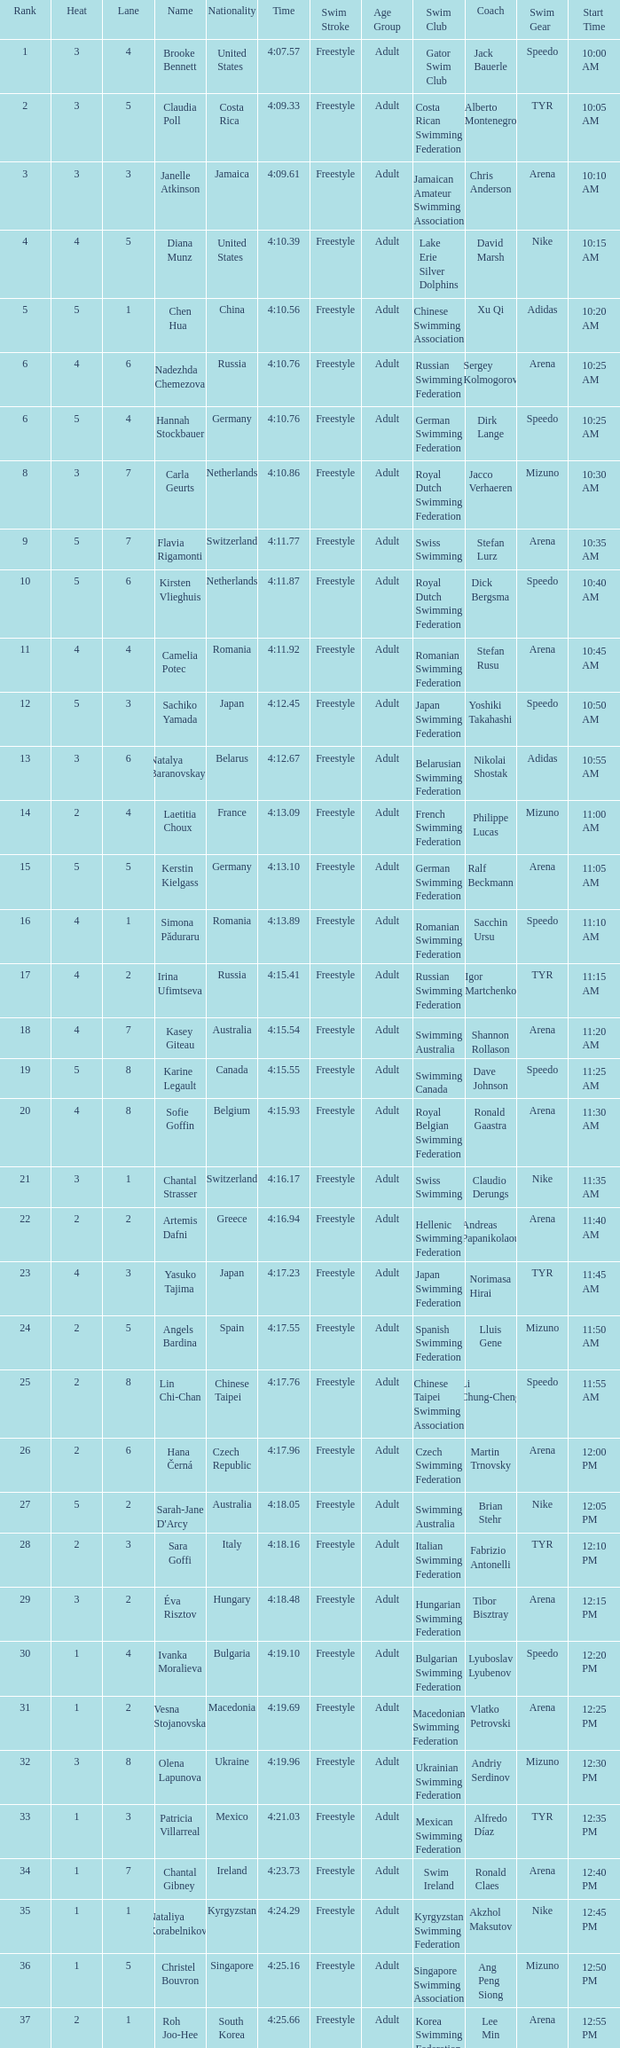Name the total number of lane for brooke bennett and rank less than 1 0.0. 